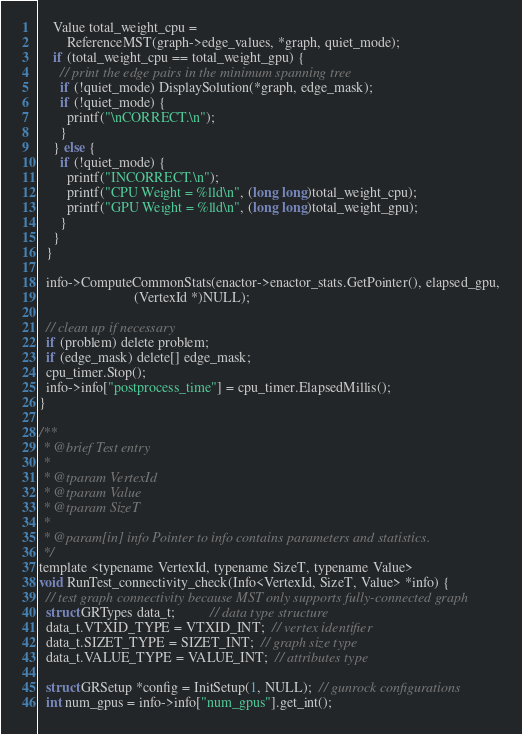Convert code to text. <code><loc_0><loc_0><loc_500><loc_500><_Cuda_>    Value total_weight_cpu =
        ReferenceMST(graph->edge_values, *graph, quiet_mode);
    if (total_weight_cpu == total_weight_gpu) {
      // print the edge pairs in the minimum spanning tree
      if (!quiet_mode) DisplaySolution(*graph, edge_mask);
      if (!quiet_mode) {
        printf("\nCORRECT.\n");
      }
    } else {
      if (!quiet_mode) {
        printf("INCORRECT.\n");
        printf("CPU Weight = %lld\n", (long long)total_weight_cpu);
        printf("GPU Weight = %lld\n", (long long)total_weight_gpu);
      }
    }
  }

  info->ComputeCommonStats(enactor->enactor_stats.GetPointer(), elapsed_gpu,
                           (VertexId *)NULL);

  // clean up if necessary
  if (problem) delete problem;
  if (edge_mask) delete[] edge_mask;
  cpu_timer.Stop();
  info->info["postprocess_time"] = cpu_timer.ElapsedMillis();
}

/**
 * @brief Test entry
 *
 * @tparam VertexId
 * @tparam Value
 * @tparam SizeT
 *
 * @param[in] info Pointer to info contains parameters and statistics.
 */
template <typename VertexId, typename SizeT, typename Value>
void RunTest_connectivity_check(Info<VertexId, SizeT, Value> *info) {
  // test graph connectivity because MST only supports fully-connected graph
  struct GRTypes data_t;          // data type structure
  data_t.VTXID_TYPE = VTXID_INT;  // vertex identifier
  data_t.SIZET_TYPE = SIZET_INT;  // graph size type
  data_t.VALUE_TYPE = VALUE_INT;  // attributes type

  struct GRSetup *config = InitSetup(1, NULL);  // gunrock configurations
  int num_gpus = info->info["num_gpus"].get_int();</code> 